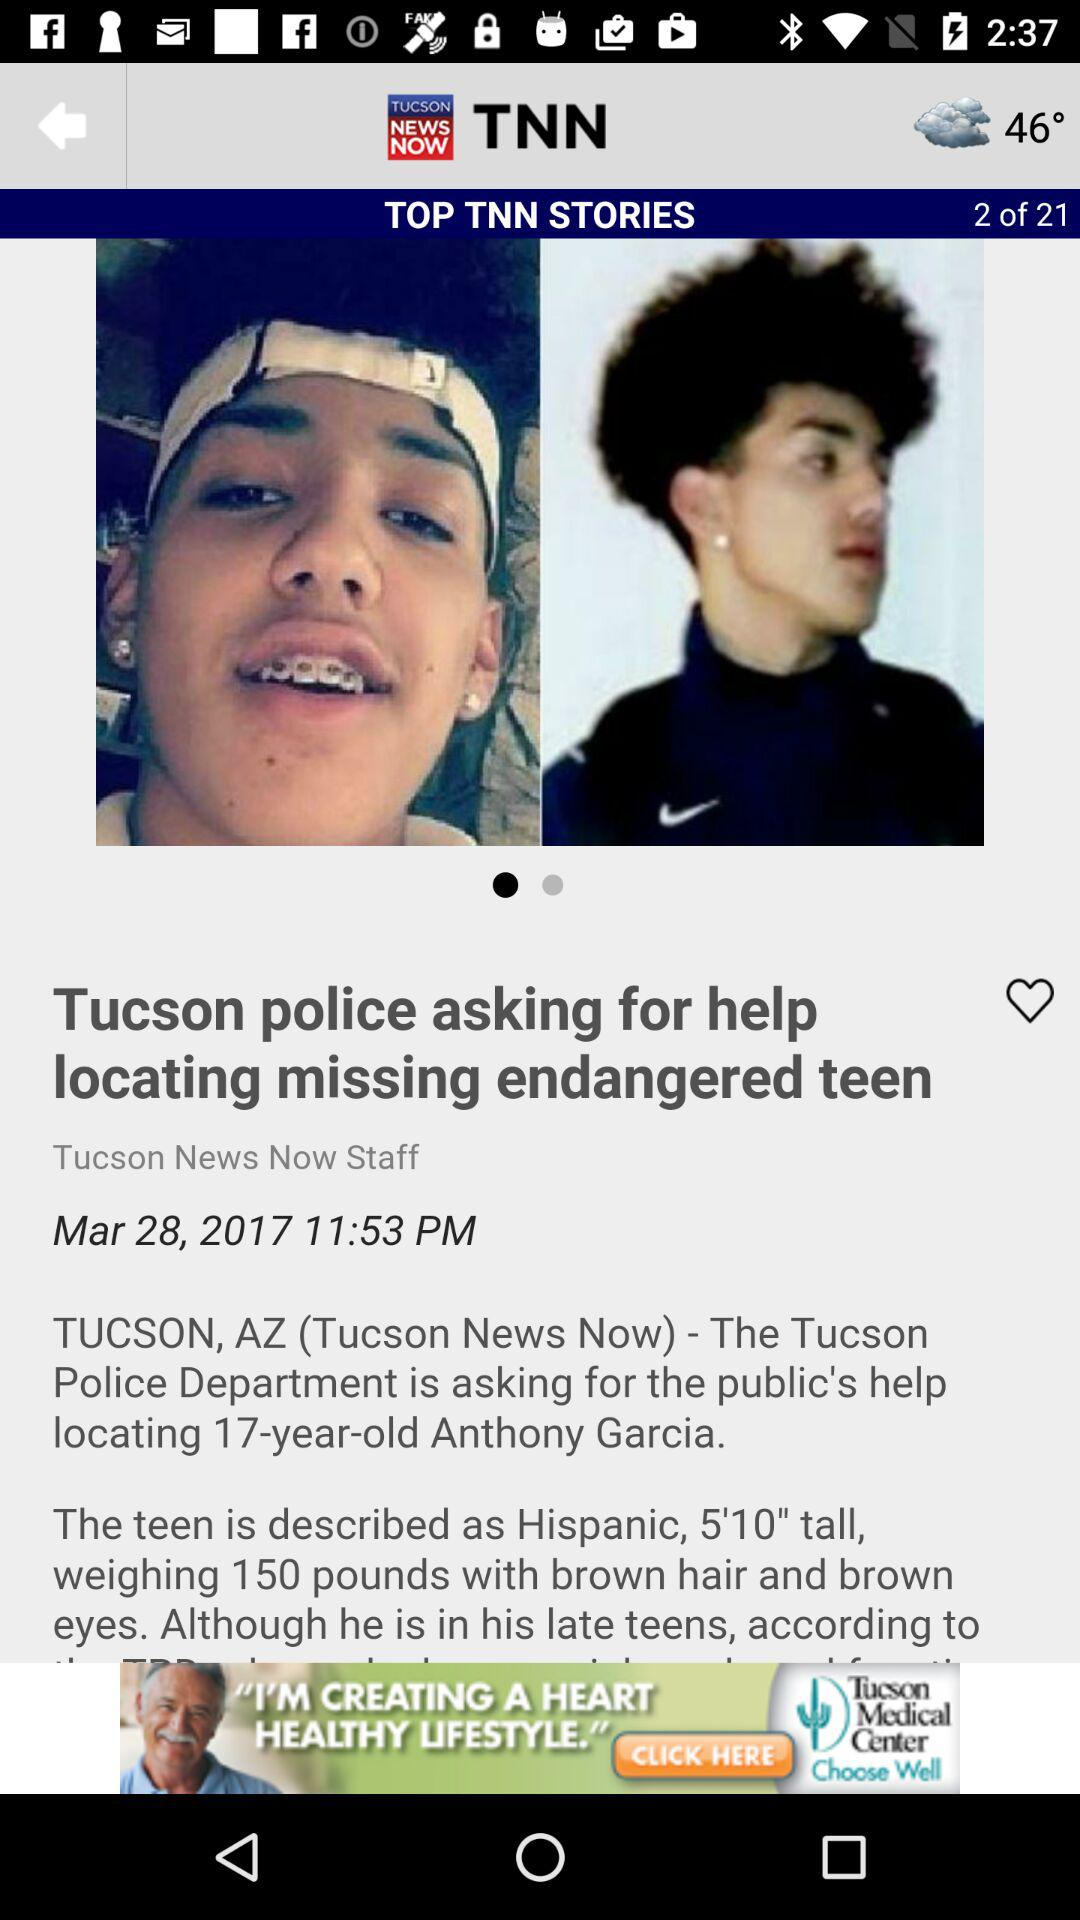What's the age of Anthony Garcia? Anthony Garcia is 17 years old. 